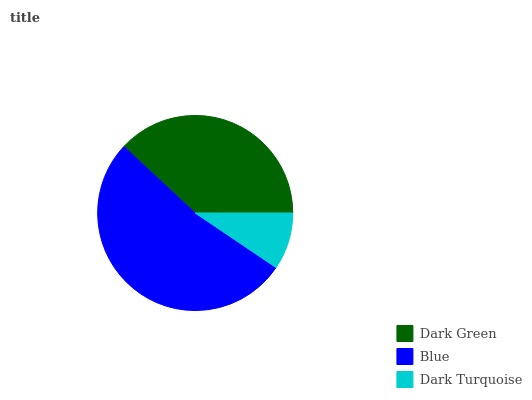Is Dark Turquoise the minimum?
Answer yes or no. Yes. Is Blue the maximum?
Answer yes or no. Yes. Is Blue the minimum?
Answer yes or no. No. Is Dark Turquoise the maximum?
Answer yes or no. No. Is Blue greater than Dark Turquoise?
Answer yes or no. Yes. Is Dark Turquoise less than Blue?
Answer yes or no. Yes. Is Dark Turquoise greater than Blue?
Answer yes or no. No. Is Blue less than Dark Turquoise?
Answer yes or no. No. Is Dark Green the high median?
Answer yes or no. Yes. Is Dark Green the low median?
Answer yes or no. Yes. Is Blue the high median?
Answer yes or no. No. Is Blue the low median?
Answer yes or no. No. 